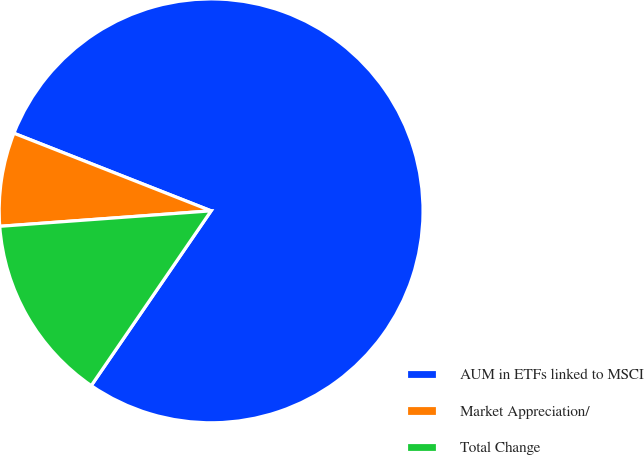Convert chart. <chart><loc_0><loc_0><loc_500><loc_500><pie_chart><fcel>AUM in ETFs linked to MSCI<fcel>Market Appreciation/<fcel>Total Change<nl><fcel>78.6%<fcel>7.13%<fcel>14.27%<nl></chart> 